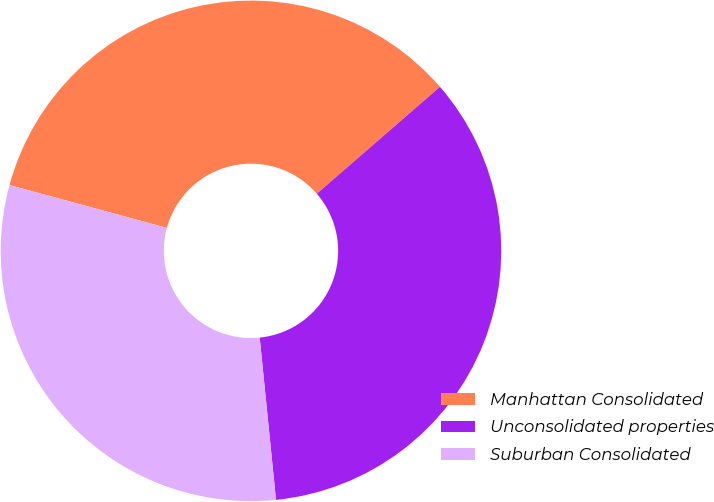Convert chart. <chart><loc_0><loc_0><loc_500><loc_500><pie_chart><fcel>Manhattan Consolidated<fcel>Unconsolidated properties<fcel>Suburban Consolidated<nl><fcel>34.39%<fcel>34.78%<fcel>30.83%<nl></chart> 